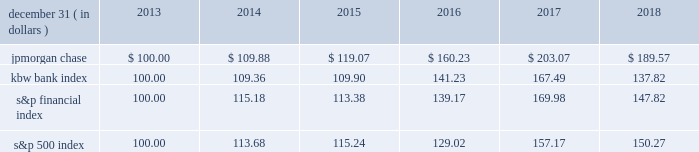Jpmorgan chase & co./2018 form 10-k 41 five-year stock performance the table and graph compare the five-year cumulative total return for jpmorgan chase & co .
( 201cjpmorgan chase 201d or the 201cfirm 201d ) common stock with the cumulative return of the s&p 500 index , the kbw bank index and the s&p financial index .
The s&p 500 index is a commonly referenced equity benchmark in the united states of america ( 201cu.s . 201d ) , consisting of leading companies from different economic sectors .
The kbw bank index seeks to reflect the performance of banks and thrifts that are publicly traded in the u.s .
And is composed of leading national money center and regional banks and thrifts .
The s&p financial index is an index of financial companies , all of which are components of the s&p 500 .
The firm is a component of all three industry indices .
The table and graph assume simultaneous investments of $ 100 on december 31 , 2013 , in jpmorgan chase common stock and in each of the above indices .
The comparison assumes that all dividends are reinvested .
December 31 , ( in dollars ) 2013 2014 2015 2016 2017 2018 .
December 31 , ( in dollars ) .
What was the average uncompounded annual return for jpmorgan chase for the five year period? 
Computations: (189.57 / 5)
Answer: 37.914. Jpmorgan chase & co./2018 form 10-k 41 five-year stock performance the table and graph compare the five-year cumulative total return for jpmorgan chase & co .
( 201cjpmorgan chase 201d or the 201cfirm 201d ) common stock with the cumulative return of the s&p 500 index , the kbw bank index and the s&p financial index .
The s&p 500 index is a commonly referenced equity benchmark in the united states of america ( 201cu.s . 201d ) , consisting of leading companies from different economic sectors .
The kbw bank index seeks to reflect the performance of banks and thrifts that are publicly traded in the u.s .
And is composed of leading national money center and regional banks and thrifts .
The s&p financial index is an index of financial companies , all of which are components of the s&p 500 .
The firm is a component of all three industry indices .
The table and graph assume simultaneous investments of $ 100 on december 31 , 2013 , in jpmorgan chase common stock and in each of the above indices .
The comparison assumes that all dividends are reinvested .
December 31 , ( in dollars ) 2013 2014 2015 2016 2017 2018 .
December 31 , ( in dollars ) .
Based on the review of the stock perfomance what was the ratio of the jpmorgan chase in 2017 to 3 kbw bank index? 
Computations: (203.07 / 167.49)
Answer: 1.21243. 